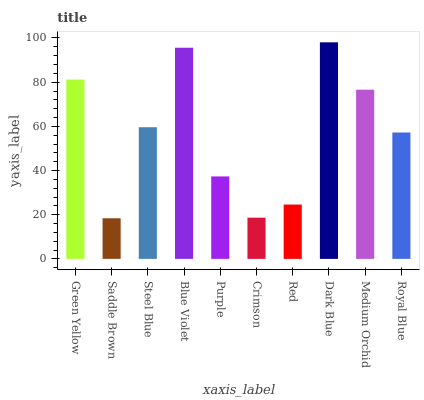Is Saddle Brown the minimum?
Answer yes or no. Yes. Is Dark Blue the maximum?
Answer yes or no. Yes. Is Steel Blue the minimum?
Answer yes or no. No. Is Steel Blue the maximum?
Answer yes or no. No. Is Steel Blue greater than Saddle Brown?
Answer yes or no. Yes. Is Saddle Brown less than Steel Blue?
Answer yes or no. Yes. Is Saddle Brown greater than Steel Blue?
Answer yes or no. No. Is Steel Blue less than Saddle Brown?
Answer yes or no. No. Is Steel Blue the high median?
Answer yes or no. Yes. Is Royal Blue the low median?
Answer yes or no. Yes. Is Green Yellow the high median?
Answer yes or no. No. Is Medium Orchid the low median?
Answer yes or no. No. 